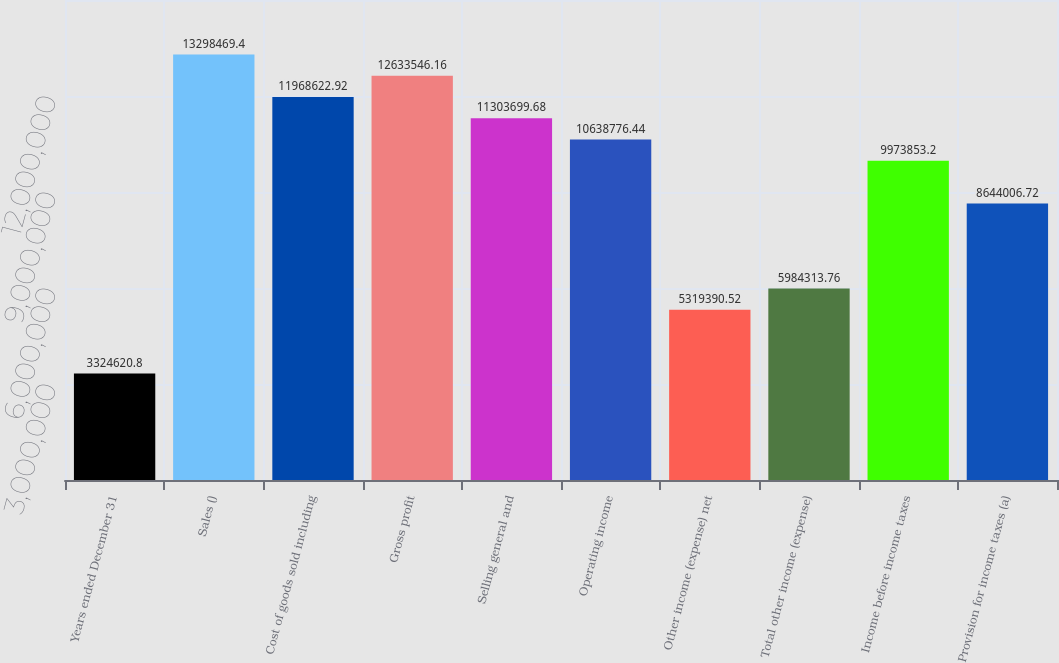<chart> <loc_0><loc_0><loc_500><loc_500><bar_chart><fcel>Years ended December 31<fcel>Sales ()<fcel>Cost of goods sold including<fcel>Gross profit<fcel>Selling general and<fcel>Operating income<fcel>Other income (expense) net<fcel>Total other income (expense)<fcel>Income before income taxes<fcel>Provision for income taxes (a)<nl><fcel>3.32462e+06<fcel>1.32985e+07<fcel>1.19686e+07<fcel>1.26335e+07<fcel>1.13037e+07<fcel>1.06388e+07<fcel>5.31939e+06<fcel>5.98431e+06<fcel>9.97385e+06<fcel>8.64401e+06<nl></chart> 